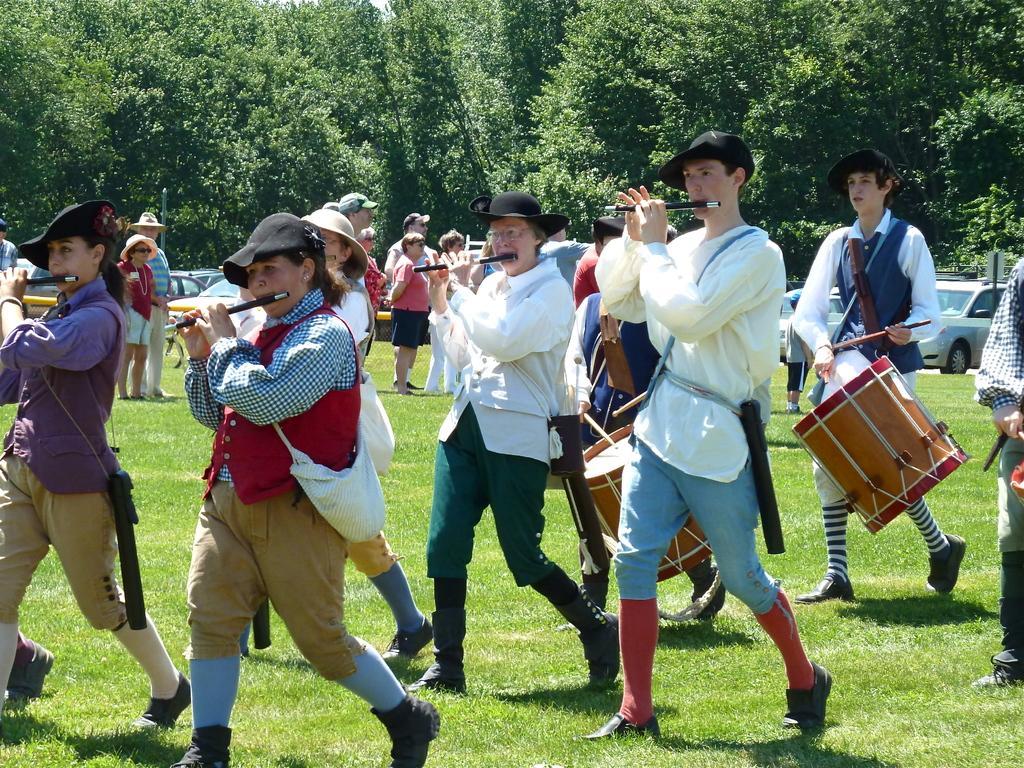How would you summarize this image in a sentence or two? In this image I can see number of people with musical instruments. In the background I can see trees and number of vehicles. 